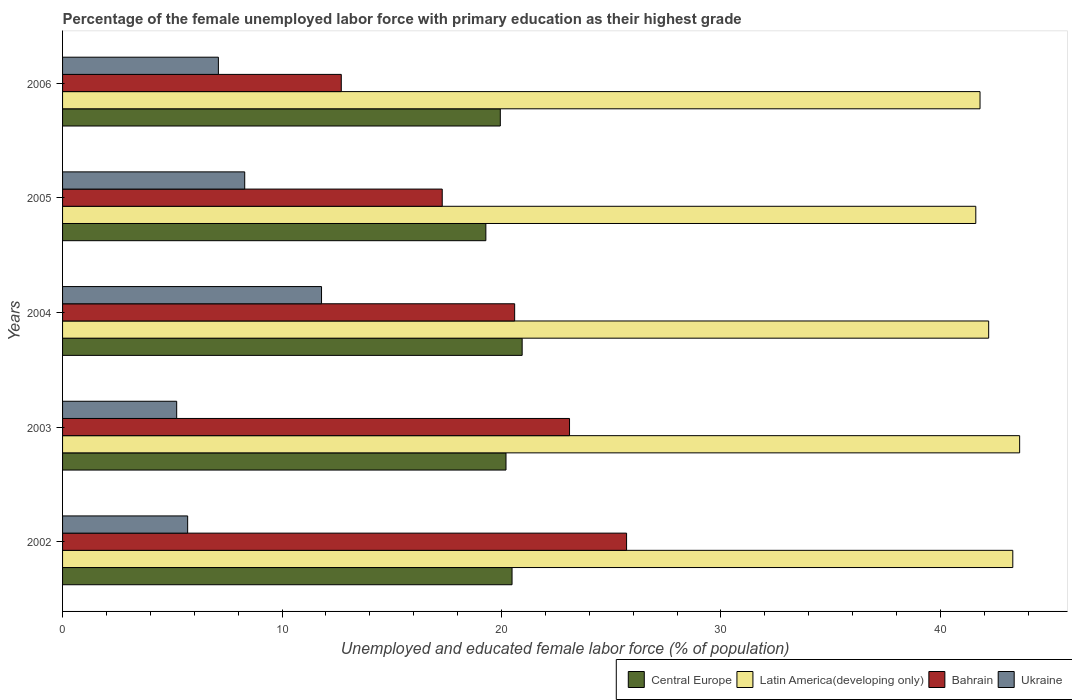How many different coloured bars are there?
Ensure brevity in your answer.  4. How many bars are there on the 5th tick from the bottom?
Ensure brevity in your answer.  4. What is the label of the 2nd group of bars from the top?
Ensure brevity in your answer.  2005. What is the percentage of the unemployed female labor force with primary education in Ukraine in 2002?
Provide a short and direct response. 5.7. Across all years, what is the maximum percentage of the unemployed female labor force with primary education in Bahrain?
Offer a terse response. 25.7. Across all years, what is the minimum percentage of the unemployed female labor force with primary education in Latin America(developing only)?
Offer a very short reply. 41.61. What is the total percentage of the unemployed female labor force with primary education in Latin America(developing only) in the graph?
Ensure brevity in your answer.  212.52. What is the difference between the percentage of the unemployed female labor force with primary education in Ukraine in 2002 and that in 2006?
Make the answer very short. -1.4. What is the difference between the percentage of the unemployed female labor force with primary education in Latin America(developing only) in 2004 and the percentage of the unemployed female labor force with primary education in Ukraine in 2003?
Provide a succinct answer. 37. What is the average percentage of the unemployed female labor force with primary education in Bahrain per year?
Ensure brevity in your answer.  19.88. In the year 2003, what is the difference between the percentage of the unemployed female labor force with primary education in Ukraine and percentage of the unemployed female labor force with primary education in Central Europe?
Your response must be concise. -15.01. What is the ratio of the percentage of the unemployed female labor force with primary education in Ukraine in 2002 to that in 2003?
Provide a succinct answer. 1.1. Is the percentage of the unemployed female labor force with primary education in Latin America(developing only) in 2002 less than that in 2004?
Provide a short and direct response. No. Is the difference between the percentage of the unemployed female labor force with primary education in Ukraine in 2005 and 2006 greater than the difference between the percentage of the unemployed female labor force with primary education in Central Europe in 2005 and 2006?
Keep it short and to the point. Yes. What is the difference between the highest and the second highest percentage of the unemployed female labor force with primary education in Central Europe?
Your answer should be compact. 0.46. What is the difference between the highest and the lowest percentage of the unemployed female labor force with primary education in Ukraine?
Keep it short and to the point. 6.6. In how many years, is the percentage of the unemployed female labor force with primary education in Ukraine greater than the average percentage of the unemployed female labor force with primary education in Ukraine taken over all years?
Offer a very short reply. 2. Is the sum of the percentage of the unemployed female labor force with primary education in Bahrain in 2003 and 2004 greater than the maximum percentage of the unemployed female labor force with primary education in Latin America(developing only) across all years?
Provide a succinct answer. Yes. Is it the case that in every year, the sum of the percentage of the unemployed female labor force with primary education in Latin America(developing only) and percentage of the unemployed female labor force with primary education in Central Europe is greater than the sum of percentage of the unemployed female labor force with primary education in Ukraine and percentage of the unemployed female labor force with primary education in Bahrain?
Give a very brief answer. Yes. What does the 2nd bar from the top in 2004 represents?
Your response must be concise. Bahrain. What does the 1st bar from the bottom in 2005 represents?
Provide a succinct answer. Central Europe. Is it the case that in every year, the sum of the percentage of the unemployed female labor force with primary education in Ukraine and percentage of the unemployed female labor force with primary education in Bahrain is greater than the percentage of the unemployed female labor force with primary education in Latin America(developing only)?
Provide a succinct answer. No. How many years are there in the graph?
Your answer should be very brief. 5. Are the values on the major ticks of X-axis written in scientific E-notation?
Your answer should be compact. No. Where does the legend appear in the graph?
Offer a very short reply. Bottom right. What is the title of the graph?
Your response must be concise. Percentage of the female unemployed labor force with primary education as their highest grade. What is the label or title of the X-axis?
Your response must be concise. Unemployed and educated female labor force (% of population). What is the label or title of the Y-axis?
Offer a very short reply. Years. What is the Unemployed and educated female labor force (% of population) of Central Europe in 2002?
Ensure brevity in your answer.  20.48. What is the Unemployed and educated female labor force (% of population) of Latin America(developing only) in 2002?
Keep it short and to the point. 43.3. What is the Unemployed and educated female labor force (% of population) in Bahrain in 2002?
Your answer should be compact. 25.7. What is the Unemployed and educated female labor force (% of population) of Ukraine in 2002?
Make the answer very short. 5.7. What is the Unemployed and educated female labor force (% of population) of Central Europe in 2003?
Your answer should be compact. 20.21. What is the Unemployed and educated female labor force (% of population) of Latin America(developing only) in 2003?
Keep it short and to the point. 43.61. What is the Unemployed and educated female labor force (% of population) of Bahrain in 2003?
Your response must be concise. 23.1. What is the Unemployed and educated female labor force (% of population) in Ukraine in 2003?
Your response must be concise. 5.2. What is the Unemployed and educated female labor force (% of population) in Central Europe in 2004?
Keep it short and to the point. 20.94. What is the Unemployed and educated female labor force (% of population) in Latin America(developing only) in 2004?
Keep it short and to the point. 42.2. What is the Unemployed and educated female labor force (% of population) in Bahrain in 2004?
Your answer should be compact. 20.6. What is the Unemployed and educated female labor force (% of population) in Ukraine in 2004?
Keep it short and to the point. 11.8. What is the Unemployed and educated female labor force (% of population) in Central Europe in 2005?
Provide a short and direct response. 19.29. What is the Unemployed and educated female labor force (% of population) in Latin America(developing only) in 2005?
Provide a succinct answer. 41.61. What is the Unemployed and educated female labor force (% of population) in Bahrain in 2005?
Provide a short and direct response. 17.3. What is the Unemployed and educated female labor force (% of population) of Ukraine in 2005?
Make the answer very short. 8.3. What is the Unemployed and educated female labor force (% of population) in Central Europe in 2006?
Offer a terse response. 19.95. What is the Unemployed and educated female labor force (% of population) in Latin America(developing only) in 2006?
Your answer should be very brief. 41.81. What is the Unemployed and educated female labor force (% of population) of Bahrain in 2006?
Ensure brevity in your answer.  12.7. What is the Unemployed and educated female labor force (% of population) of Ukraine in 2006?
Ensure brevity in your answer.  7.1. Across all years, what is the maximum Unemployed and educated female labor force (% of population) in Central Europe?
Offer a very short reply. 20.94. Across all years, what is the maximum Unemployed and educated female labor force (% of population) of Latin America(developing only)?
Ensure brevity in your answer.  43.61. Across all years, what is the maximum Unemployed and educated female labor force (% of population) of Bahrain?
Offer a very short reply. 25.7. Across all years, what is the maximum Unemployed and educated female labor force (% of population) of Ukraine?
Ensure brevity in your answer.  11.8. Across all years, what is the minimum Unemployed and educated female labor force (% of population) of Central Europe?
Offer a terse response. 19.29. Across all years, what is the minimum Unemployed and educated female labor force (% of population) in Latin America(developing only)?
Your response must be concise. 41.61. Across all years, what is the minimum Unemployed and educated female labor force (% of population) of Bahrain?
Your answer should be compact. 12.7. Across all years, what is the minimum Unemployed and educated female labor force (% of population) of Ukraine?
Offer a terse response. 5.2. What is the total Unemployed and educated female labor force (% of population) of Central Europe in the graph?
Your answer should be compact. 100.86. What is the total Unemployed and educated female labor force (% of population) of Latin America(developing only) in the graph?
Give a very brief answer. 212.52. What is the total Unemployed and educated female labor force (% of population) of Bahrain in the graph?
Give a very brief answer. 99.4. What is the total Unemployed and educated female labor force (% of population) of Ukraine in the graph?
Offer a very short reply. 38.1. What is the difference between the Unemployed and educated female labor force (% of population) in Central Europe in 2002 and that in 2003?
Offer a very short reply. 0.28. What is the difference between the Unemployed and educated female labor force (% of population) of Latin America(developing only) in 2002 and that in 2003?
Your answer should be compact. -0.31. What is the difference between the Unemployed and educated female labor force (% of population) in Bahrain in 2002 and that in 2003?
Ensure brevity in your answer.  2.6. What is the difference between the Unemployed and educated female labor force (% of population) of Central Europe in 2002 and that in 2004?
Ensure brevity in your answer.  -0.46. What is the difference between the Unemployed and educated female labor force (% of population) of Latin America(developing only) in 2002 and that in 2004?
Offer a terse response. 1.1. What is the difference between the Unemployed and educated female labor force (% of population) in Bahrain in 2002 and that in 2004?
Keep it short and to the point. 5.1. What is the difference between the Unemployed and educated female labor force (% of population) of Ukraine in 2002 and that in 2004?
Offer a terse response. -6.1. What is the difference between the Unemployed and educated female labor force (% of population) in Central Europe in 2002 and that in 2005?
Give a very brief answer. 1.19. What is the difference between the Unemployed and educated female labor force (% of population) in Latin America(developing only) in 2002 and that in 2005?
Make the answer very short. 1.69. What is the difference between the Unemployed and educated female labor force (% of population) of Bahrain in 2002 and that in 2005?
Make the answer very short. 8.4. What is the difference between the Unemployed and educated female labor force (% of population) of Ukraine in 2002 and that in 2005?
Keep it short and to the point. -2.6. What is the difference between the Unemployed and educated female labor force (% of population) of Central Europe in 2002 and that in 2006?
Your response must be concise. 0.53. What is the difference between the Unemployed and educated female labor force (% of population) of Latin America(developing only) in 2002 and that in 2006?
Your answer should be compact. 1.49. What is the difference between the Unemployed and educated female labor force (% of population) in Bahrain in 2002 and that in 2006?
Offer a very short reply. 13. What is the difference between the Unemployed and educated female labor force (% of population) of Ukraine in 2002 and that in 2006?
Ensure brevity in your answer.  -1.4. What is the difference between the Unemployed and educated female labor force (% of population) in Central Europe in 2003 and that in 2004?
Your answer should be compact. -0.74. What is the difference between the Unemployed and educated female labor force (% of population) of Latin America(developing only) in 2003 and that in 2004?
Your answer should be very brief. 1.41. What is the difference between the Unemployed and educated female labor force (% of population) of Central Europe in 2003 and that in 2005?
Give a very brief answer. 0.92. What is the difference between the Unemployed and educated female labor force (% of population) in Latin America(developing only) in 2003 and that in 2005?
Provide a succinct answer. 2. What is the difference between the Unemployed and educated female labor force (% of population) of Bahrain in 2003 and that in 2005?
Your answer should be compact. 5.8. What is the difference between the Unemployed and educated female labor force (% of population) in Ukraine in 2003 and that in 2005?
Make the answer very short. -3.1. What is the difference between the Unemployed and educated female labor force (% of population) in Central Europe in 2003 and that in 2006?
Provide a succinct answer. 0.26. What is the difference between the Unemployed and educated female labor force (% of population) in Latin America(developing only) in 2003 and that in 2006?
Offer a very short reply. 1.8. What is the difference between the Unemployed and educated female labor force (% of population) in Bahrain in 2003 and that in 2006?
Your answer should be very brief. 10.4. What is the difference between the Unemployed and educated female labor force (% of population) in Central Europe in 2004 and that in 2005?
Offer a terse response. 1.65. What is the difference between the Unemployed and educated female labor force (% of population) of Latin America(developing only) in 2004 and that in 2005?
Provide a succinct answer. 0.59. What is the difference between the Unemployed and educated female labor force (% of population) in Bahrain in 2004 and that in 2005?
Provide a succinct answer. 3.3. What is the difference between the Unemployed and educated female labor force (% of population) of Central Europe in 2004 and that in 2006?
Your answer should be very brief. 1. What is the difference between the Unemployed and educated female labor force (% of population) in Latin America(developing only) in 2004 and that in 2006?
Your answer should be very brief. 0.39. What is the difference between the Unemployed and educated female labor force (% of population) of Bahrain in 2004 and that in 2006?
Your response must be concise. 7.9. What is the difference between the Unemployed and educated female labor force (% of population) of Central Europe in 2005 and that in 2006?
Offer a terse response. -0.66. What is the difference between the Unemployed and educated female labor force (% of population) of Latin America(developing only) in 2005 and that in 2006?
Provide a succinct answer. -0.19. What is the difference between the Unemployed and educated female labor force (% of population) in Bahrain in 2005 and that in 2006?
Ensure brevity in your answer.  4.6. What is the difference between the Unemployed and educated female labor force (% of population) in Central Europe in 2002 and the Unemployed and educated female labor force (% of population) in Latin America(developing only) in 2003?
Keep it short and to the point. -23.13. What is the difference between the Unemployed and educated female labor force (% of population) in Central Europe in 2002 and the Unemployed and educated female labor force (% of population) in Bahrain in 2003?
Keep it short and to the point. -2.62. What is the difference between the Unemployed and educated female labor force (% of population) in Central Europe in 2002 and the Unemployed and educated female labor force (% of population) in Ukraine in 2003?
Offer a terse response. 15.28. What is the difference between the Unemployed and educated female labor force (% of population) of Latin America(developing only) in 2002 and the Unemployed and educated female labor force (% of population) of Bahrain in 2003?
Provide a short and direct response. 20.2. What is the difference between the Unemployed and educated female labor force (% of population) in Latin America(developing only) in 2002 and the Unemployed and educated female labor force (% of population) in Ukraine in 2003?
Ensure brevity in your answer.  38.1. What is the difference between the Unemployed and educated female labor force (% of population) in Bahrain in 2002 and the Unemployed and educated female labor force (% of population) in Ukraine in 2003?
Ensure brevity in your answer.  20.5. What is the difference between the Unemployed and educated female labor force (% of population) of Central Europe in 2002 and the Unemployed and educated female labor force (% of population) of Latin America(developing only) in 2004?
Provide a short and direct response. -21.72. What is the difference between the Unemployed and educated female labor force (% of population) in Central Europe in 2002 and the Unemployed and educated female labor force (% of population) in Bahrain in 2004?
Keep it short and to the point. -0.12. What is the difference between the Unemployed and educated female labor force (% of population) of Central Europe in 2002 and the Unemployed and educated female labor force (% of population) of Ukraine in 2004?
Your answer should be compact. 8.68. What is the difference between the Unemployed and educated female labor force (% of population) of Latin America(developing only) in 2002 and the Unemployed and educated female labor force (% of population) of Bahrain in 2004?
Offer a terse response. 22.7. What is the difference between the Unemployed and educated female labor force (% of population) of Latin America(developing only) in 2002 and the Unemployed and educated female labor force (% of population) of Ukraine in 2004?
Provide a succinct answer. 31.5. What is the difference between the Unemployed and educated female labor force (% of population) in Bahrain in 2002 and the Unemployed and educated female labor force (% of population) in Ukraine in 2004?
Make the answer very short. 13.9. What is the difference between the Unemployed and educated female labor force (% of population) in Central Europe in 2002 and the Unemployed and educated female labor force (% of population) in Latin America(developing only) in 2005?
Your answer should be compact. -21.13. What is the difference between the Unemployed and educated female labor force (% of population) of Central Europe in 2002 and the Unemployed and educated female labor force (% of population) of Bahrain in 2005?
Your response must be concise. 3.18. What is the difference between the Unemployed and educated female labor force (% of population) in Central Europe in 2002 and the Unemployed and educated female labor force (% of population) in Ukraine in 2005?
Ensure brevity in your answer.  12.18. What is the difference between the Unemployed and educated female labor force (% of population) in Latin America(developing only) in 2002 and the Unemployed and educated female labor force (% of population) in Bahrain in 2005?
Provide a short and direct response. 26. What is the difference between the Unemployed and educated female labor force (% of population) of Latin America(developing only) in 2002 and the Unemployed and educated female labor force (% of population) of Ukraine in 2005?
Keep it short and to the point. 35. What is the difference between the Unemployed and educated female labor force (% of population) in Central Europe in 2002 and the Unemployed and educated female labor force (% of population) in Latin America(developing only) in 2006?
Your response must be concise. -21.32. What is the difference between the Unemployed and educated female labor force (% of population) in Central Europe in 2002 and the Unemployed and educated female labor force (% of population) in Bahrain in 2006?
Your answer should be compact. 7.78. What is the difference between the Unemployed and educated female labor force (% of population) of Central Europe in 2002 and the Unemployed and educated female labor force (% of population) of Ukraine in 2006?
Make the answer very short. 13.38. What is the difference between the Unemployed and educated female labor force (% of population) of Latin America(developing only) in 2002 and the Unemployed and educated female labor force (% of population) of Bahrain in 2006?
Your response must be concise. 30.6. What is the difference between the Unemployed and educated female labor force (% of population) in Latin America(developing only) in 2002 and the Unemployed and educated female labor force (% of population) in Ukraine in 2006?
Offer a very short reply. 36.2. What is the difference between the Unemployed and educated female labor force (% of population) of Bahrain in 2002 and the Unemployed and educated female labor force (% of population) of Ukraine in 2006?
Your answer should be compact. 18.6. What is the difference between the Unemployed and educated female labor force (% of population) in Central Europe in 2003 and the Unemployed and educated female labor force (% of population) in Latin America(developing only) in 2004?
Provide a short and direct response. -21.99. What is the difference between the Unemployed and educated female labor force (% of population) of Central Europe in 2003 and the Unemployed and educated female labor force (% of population) of Bahrain in 2004?
Offer a terse response. -0.39. What is the difference between the Unemployed and educated female labor force (% of population) in Central Europe in 2003 and the Unemployed and educated female labor force (% of population) in Ukraine in 2004?
Offer a very short reply. 8.41. What is the difference between the Unemployed and educated female labor force (% of population) of Latin America(developing only) in 2003 and the Unemployed and educated female labor force (% of population) of Bahrain in 2004?
Your answer should be very brief. 23.01. What is the difference between the Unemployed and educated female labor force (% of population) in Latin America(developing only) in 2003 and the Unemployed and educated female labor force (% of population) in Ukraine in 2004?
Provide a short and direct response. 31.81. What is the difference between the Unemployed and educated female labor force (% of population) in Central Europe in 2003 and the Unemployed and educated female labor force (% of population) in Latin America(developing only) in 2005?
Give a very brief answer. -21.41. What is the difference between the Unemployed and educated female labor force (% of population) in Central Europe in 2003 and the Unemployed and educated female labor force (% of population) in Bahrain in 2005?
Your answer should be compact. 2.91. What is the difference between the Unemployed and educated female labor force (% of population) in Central Europe in 2003 and the Unemployed and educated female labor force (% of population) in Ukraine in 2005?
Ensure brevity in your answer.  11.91. What is the difference between the Unemployed and educated female labor force (% of population) of Latin America(developing only) in 2003 and the Unemployed and educated female labor force (% of population) of Bahrain in 2005?
Offer a very short reply. 26.31. What is the difference between the Unemployed and educated female labor force (% of population) of Latin America(developing only) in 2003 and the Unemployed and educated female labor force (% of population) of Ukraine in 2005?
Your answer should be very brief. 35.31. What is the difference between the Unemployed and educated female labor force (% of population) of Central Europe in 2003 and the Unemployed and educated female labor force (% of population) of Latin America(developing only) in 2006?
Provide a succinct answer. -21.6. What is the difference between the Unemployed and educated female labor force (% of population) in Central Europe in 2003 and the Unemployed and educated female labor force (% of population) in Bahrain in 2006?
Your answer should be very brief. 7.51. What is the difference between the Unemployed and educated female labor force (% of population) of Central Europe in 2003 and the Unemployed and educated female labor force (% of population) of Ukraine in 2006?
Your answer should be very brief. 13.11. What is the difference between the Unemployed and educated female labor force (% of population) of Latin America(developing only) in 2003 and the Unemployed and educated female labor force (% of population) of Bahrain in 2006?
Your answer should be very brief. 30.91. What is the difference between the Unemployed and educated female labor force (% of population) of Latin America(developing only) in 2003 and the Unemployed and educated female labor force (% of population) of Ukraine in 2006?
Offer a very short reply. 36.51. What is the difference between the Unemployed and educated female labor force (% of population) of Central Europe in 2004 and the Unemployed and educated female labor force (% of population) of Latin America(developing only) in 2005?
Your answer should be very brief. -20.67. What is the difference between the Unemployed and educated female labor force (% of population) of Central Europe in 2004 and the Unemployed and educated female labor force (% of population) of Bahrain in 2005?
Provide a succinct answer. 3.64. What is the difference between the Unemployed and educated female labor force (% of population) in Central Europe in 2004 and the Unemployed and educated female labor force (% of population) in Ukraine in 2005?
Your answer should be very brief. 12.64. What is the difference between the Unemployed and educated female labor force (% of population) of Latin America(developing only) in 2004 and the Unemployed and educated female labor force (% of population) of Bahrain in 2005?
Offer a very short reply. 24.9. What is the difference between the Unemployed and educated female labor force (% of population) in Latin America(developing only) in 2004 and the Unemployed and educated female labor force (% of population) in Ukraine in 2005?
Make the answer very short. 33.9. What is the difference between the Unemployed and educated female labor force (% of population) in Central Europe in 2004 and the Unemployed and educated female labor force (% of population) in Latin America(developing only) in 2006?
Your answer should be very brief. -20.86. What is the difference between the Unemployed and educated female labor force (% of population) in Central Europe in 2004 and the Unemployed and educated female labor force (% of population) in Bahrain in 2006?
Your answer should be compact. 8.24. What is the difference between the Unemployed and educated female labor force (% of population) in Central Europe in 2004 and the Unemployed and educated female labor force (% of population) in Ukraine in 2006?
Ensure brevity in your answer.  13.84. What is the difference between the Unemployed and educated female labor force (% of population) in Latin America(developing only) in 2004 and the Unemployed and educated female labor force (% of population) in Bahrain in 2006?
Your response must be concise. 29.5. What is the difference between the Unemployed and educated female labor force (% of population) in Latin America(developing only) in 2004 and the Unemployed and educated female labor force (% of population) in Ukraine in 2006?
Ensure brevity in your answer.  35.1. What is the difference between the Unemployed and educated female labor force (% of population) of Central Europe in 2005 and the Unemployed and educated female labor force (% of population) of Latin America(developing only) in 2006?
Keep it short and to the point. -22.52. What is the difference between the Unemployed and educated female labor force (% of population) of Central Europe in 2005 and the Unemployed and educated female labor force (% of population) of Bahrain in 2006?
Keep it short and to the point. 6.59. What is the difference between the Unemployed and educated female labor force (% of population) in Central Europe in 2005 and the Unemployed and educated female labor force (% of population) in Ukraine in 2006?
Make the answer very short. 12.19. What is the difference between the Unemployed and educated female labor force (% of population) of Latin America(developing only) in 2005 and the Unemployed and educated female labor force (% of population) of Bahrain in 2006?
Your answer should be very brief. 28.91. What is the difference between the Unemployed and educated female labor force (% of population) in Latin America(developing only) in 2005 and the Unemployed and educated female labor force (% of population) in Ukraine in 2006?
Give a very brief answer. 34.51. What is the average Unemployed and educated female labor force (% of population) in Central Europe per year?
Keep it short and to the point. 20.17. What is the average Unemployed and educated female labor force (% of population) in Latin America(developing only) per year?
Give a very brief answer. 42.5. What is the average Unemployed and educated female labor force (% of population) of Bahrain per year?
Offer a very short reply. 19.88. What is the average Unemployed and educated female labor force (% of population) of Ukraine per year?
Your answer should be very brief. 7.62. In the year 2002, what is the difference between the Unemployed and educated female labor force (% of population) in Central Europe and Unemployed and educated female labor force (% of population) in Latin America(developing only)?
Your response must be concise. -22.82. In the year 2002, what is the difference between the Unemployed and educated female labor force (% of population) in Central Europe and Unemployed and educated female labor force (% of population) in Bahrain?
Your answer should be compact. -5.22. In the year 2002, what is the difference between the Unemployed and educated female labor force (% of population) of Central Europe and Unemployed and educated female labor force (% of population) of Ukraine?
Your response must be concise. 14.78. In the year 2002, what is the difference between the Unemployed and educated female labor force (% of population) of Latin America(developing only) and Unemployed and educated female labor force (% of population) of Bahrain?
Give a very brief answer. 17.6. In the year 2002, what is the difference between the Unemployed and educated female labor force (% of population) in Latin America(developing only) and Unemployed and educated female labor force (% of population) in Ukraine?
Offer a very short reply. 37.6. In the year 2002, what is the difference between the Unemployed and educated female labor force (% of population) of Bahrain and Unemployed and educated female labor force (% of population) of Ukraine?
Make the answer very short. 20. In the year 2003, what is the difference between the Unemployed and educated female labor force (% of population) in Central Europe and Unemployed and educated female labor force (% of population) in Latin America(developing only)?
Ensure brevity in your answer.  -23.4. In the year 2003, what is the difference between the Unemployed and educated female labor force (% of population) of Central Europe and Unemployed and educated female labor force (% of population) of Bahrain?
Make the answer very short. -2.89. In the year 2003, what is the difference between the Unemployed and educated female labor force (% of population) of Central Europe and Unemployed and educated female labor force (% of population) of Ukraine?
Give a very brief answer. 15.01. In the year 2003, what is the difference between the Unemployed and educated female labor force (% of population) of Latin America(developing only) and Unemployed and educated female labor force (% of population) of Bahrain?
Offer a terse response. 20.51. In the year 2003, what is the difference between the Unemployed and educated female labor force (% of population) in Latin America(developing only) and Unemployed and educated female labor force (% of population) in Ukraine?
Your response must be concise. 38.41. In the year 2003, what is the difference between the Unemployed and educated female labor force (% of population) in Bahrain and Unemployed and educated female labor force (% of population) in Ukraine?
Provide a succinct answer. 17.9. In the year 2004, what is the difference between the Unemployed and educated female labor force (% of population) of Central Europe and Unemployed and educated female labor force (% of population) of Latin America(developing only)?
Keep it short and to the point. -21.26. In the year 2004, what is the difference between the Unemployed and educated female labor force (% of population) in Central Europe and Unemployed and educated female labor force (% of population) in Bahrain?
Your answer should be very brief. 0.34. In the year 2004, what is the difference between the Unemployed and educated female labor force (% of population) of Central Europe and Unemployed and educated female labor force (% of population) of Ukraine?
Provide a short and direct response. 9.14. In the year 2004, what is the difference between the Unemployed and educated female labor force (% of population) in Latin America(developing only) and Unemployed and educated female labor force (% of population) in Bahrain?
Keep it short and to the point. 21.6. In the year 2004, what is the difference between the Unemployed and educated female labor force (% of population) in Latin America(developing only) and Unemployed and educated female labor force (% of population) in Ukraine?
Keep it short and to the point. 30.4. In the year 2004, what is the difference between the Unemployed and educated female labor force (% of population) in Bahrain and Unemployed and educated female labor force (% of population) in Ukraine?
Your answer should be very brief. 8.8. In the year 2005, what is the difference between the Unemployed and educated female labor force (% of population) of Central Europe and Unemployed and educated female labor force (% of population) of Latin America(developing only)?
Give a very brief answer. -22.32. In the year 2005, what is the difference between the Unemployed and educated female labor force (% of population) of Central Europe and Unemployed and educated female labor force (% of population) of Bahrain?
Your answer should be compact. 1.99. In the year 2005, what is the difference between the Unemployed and educated female labor force (% of population) of Central Europe and Unemployed and educated female labor force (% of population) of Ukraine?
Offer a terse response. 10.99. In the year 2005, what is the difference between the Unemployed and educated female labor force (% of population) in Latin America(developing only) and Unemployed and educated female labor force (% of population) in Bahrain?
Your response must be concise. 24.31. In the year 2005, what is the difference between the Unemployed and educated female labor force (% of population) of Latin America(developing only) and Unemployed and educated female labor force (% of population) of Ukraine?
Offer a very short reply. 33.31. In the year 2006, what is the difference between the Unemployed and educated female labor force (% of population) of Central Europe and Unemployed and educated female labor force (% of population) of Latin America(developing only)?
Your answer should be very brief. -21.86. In the year 2006, what is the difference between the Unemployed and educated female labor force (% of population) of Central Europe and Unemployed and educated female labor force (% of population) of Bahrain?
Offer a terse response. 7.25. In the year 2006, what is the difference between the Unemployed and educated female labor force (% of population) in Central Europe and Unemployed and educated female labor force (% of population) in Ukraine?
Your response must be concise. 12.85. In the year 2006, what is the difference between the Unemployed and educated female labor force (% of population) of Latin America(developing only) and Unemployed and educated female labor force (% of population) of Bahrain?
Provide a short and direct response. 29.11. In the year 2006, what is the difference between the Unemployed and educated female labor force (% of population) in Latin America(developing only) and Unemployed and educated female labor force (% of population) in Ukraine?
Offer a very short reply. 34.71. In the year 2006, what is the difference between the Unemployed and educated female labor force (% of population) in Bahrain and Unemployed and educated female labor force (% of population) in Ukraine?
Offer a very short reply. 5.6. What is the ratio of the Unemployed and educated female labor force (% of population) in Central Europe in 2002 to that in 2003?
Provide a succinct answer. 1.01. What is the ratio of the Unemployed and educated female labor force (% of population) in Latin America(developing only) in 2002 to that in 2003?
Your answer should be very brief. 0.99. What is the ratio of the Unemployed and educated female labor force (% of population) of Bahrain in 2002 to that in 2003?
Your answer should be very brief. 1.11. What is the ratio of the Unemployed and educated female labor force (% of population) of Ukraine in 2002 to that in 2003?
Make the answer very short. 1.1. What is the ratio of the Unemployed and educated female labor force (% of population) in Central Europe in 2002 to that in 2004?
Make the answer very short. 0.98. What is the ratio of the Unemployed and educated female labor force (% of population) of Latin America(developing only) in 2002 to that in 2004?
Offer a terse response. 1.03. What is the ratio of the Unemployed and educated female labor force (% of population) in Bahrain in 2002 to that in 2004?
Offer a terse response. 1.25. What is the ratio of the Unemployed and educated female labor force (% of population) in Ukraine in 2002 to that in 2004?
Ensure brevity in your answer.  0.48. What is the ratio of the Unemployed and educated female labor force (% of population) of Central Europe in 2002 to that in 2005?
Your response must be concise. 1.06. What is the ratio of the Unemployed and educated female labor force (% of population) of Latin America(developing only) in 2002 to that in 2005?
Offer a very short reply. 1.04. What is the ratio of the Unemployed and educated female labor force (% of population) of Bahrain in 2002 to that in 2005?
Offer a terse response. 1.49. What is the ratio of the Unemployed and educated female labor force (% of population) in Ukraine in 2002 to that in 2005?
Offer a very short reply. 0.69. What is the ratio of the Unemployed and educated female labor force (% of population) of Central Europe in 2002 to that in 2006?
Give a very brief answer. 1.03. What is the ratio of the Unemployed and educated female labor force (% of population) of Latin America(developing only) in 2002 to that in 2006?
Keep it short and to the point. 1.04. What is the ratio of the Unemployed and educated female labor force (% of population) of Bahrain in 2002 to that in 2006?
Offer a terse response. 2.02. What is the ratio of the Unemployed and educated female labor force (% of population) in Ukraine in 2002 to that in 2006?
Provide a succinct answer. 0.8. What is the ratio of the Unemployed and educated female labor force (% of population) in Central Europe in 2003 to that in 2004?
Give a very brief answer. 0.96. What is the ratio of the Unemployed and educated female labor force (% of population) of Latin America(developing only) in 2003 to that in 2004?
Keep it short and to the point. 1.03. What is the ratio of the Unemployed and educated female labor force (% of population) in Bahrain in 2003 to that in 2004?
Ensure brevity in your answer.  1.12. What is the ratio of the Unemployed and educated female labor force (% of population) of Ukraine in 2003 to that in 2004?
Offer a terse response. 0.44. What is the ratio of the Unemployed and educated female labor force (% of population) in Central Europe in 2003 to that in 2005?
Give a very brief answer. 1.05. What is the ratio of the Unemployed and educated female labor force (% of population) of Latin America(developing only) in 2003 to that in 2005?
Offer a terse response. 1.05. What is the ratio of the Unemployed and educated female labor force (% of population) of Bahrain in 2003 to that in 2005?
Provide a short and direct response. 1.34. What is the ratio of the Unemployed and educated female labor force (% of population) in Ukraine in 2003 to that in 2005?
Provide a succinct answer. 0.63. What is the ratio of the Unemployed and educated female labor force (% of population) in Latin America(developing only) in 2003 to that in 2006?
Give a very brief answer. 1.04. What is the ratio of the Unemployed and educated female labor force (% of population) of Bahrain in 2003 to that in 2006?
Give a very brief answer. 1.82. What is the ratio of the Unemployed and educated female labor force (% of population) of Ukraine in 2003 to that in 2006?
Make the answer very short. 0.73. What is the ratio of the Unemployed and educated female labor force (% of population) in Central Europe in 2004 to that in 2005?
Offer a terse response. 1.09. What is the ratio of the Unemployed and educated female labor force (% of population) in Latin America(developing only) in 2004 to that in 2005?
Your answer should be compact. 1.01. What is the ratio of the Unemployed and educated female labor force (% of population) in Bahrain in 2004 to that in 2005?
Provide a succinct answer. 1.19. What is the ratio of the Unemployed and educated female labor force (% of population) in Ukraine in 2004 to that in 2005?
Provide a succinct answer. 1.42. What is the ratio of the Unemployed and educated female labor force (% of population) in Central Europe in 2004 to that in 2006?
Ensure brevity in your answer.  1.05. What is the ratio of the Unemployed and educated female labor force (% of population) of Latin America(developing only) in 2004 to that in 2006?
Your response must be concise. 1.01. What is the ratio of the Unemployed and educated female labor force (% of population) of Bahrain in 2004 to that in 2006?
Make the answer very short. 1.62. What is the ratio of the Unemployed and educated female labor force (% of population) in Ukraine in 2004 to that in 2006?
Your answer should be very brief. 1.66. What is the ratio of the Unemployed and educated female labor force (% of population) of Latin America(developing only) in 2005 to that in 2006?
Make the answer very short. 1. What is the ratio of the Unemployed and educated female labor force (% of population) of Bahrain in 2005 to that in 2006?
Provide a succinct answer. 1.36. What is the ratio of the Unemployed and educated female labor force (% of population) in Ukraine in 2005 to that in 2006?
Offer a very short reply. 1.17. What is the difference between the highest and the second highest Unemployed and educated female labor force (% of population) of Central Europe?
Provide a short and direct response. 0.46. What is the difference between the highest and the second highest Unemployed and educated female labor force (% of population) in Latin America(developing only)?
Give a very brief answer. 0.31. What is the difference between the highest and the second highest Unemployed and educated female labor force (% of population) in Ukraine?
Offer a very short reply. 3.5. What is the difference between the highest and the lowest Unemployed and educated female labor force (% of population) in Central Europe?
Make the answer very short. 1.65. What is the difference between the highest and the lowest Unemployed and educated female labor force (% of population) in Latin America(developing only)?
Provide a short and direct response. 2. What is the difference between the highest and the lowest Unemployed and educated female labor force (% of population) of Bahrain?
Give a very brief answer. 13. What is the difference between the highest and the lowest Unemployed and educated female labor force (% of population) in Ukraine?
Offer a very short reply. 6.6. 